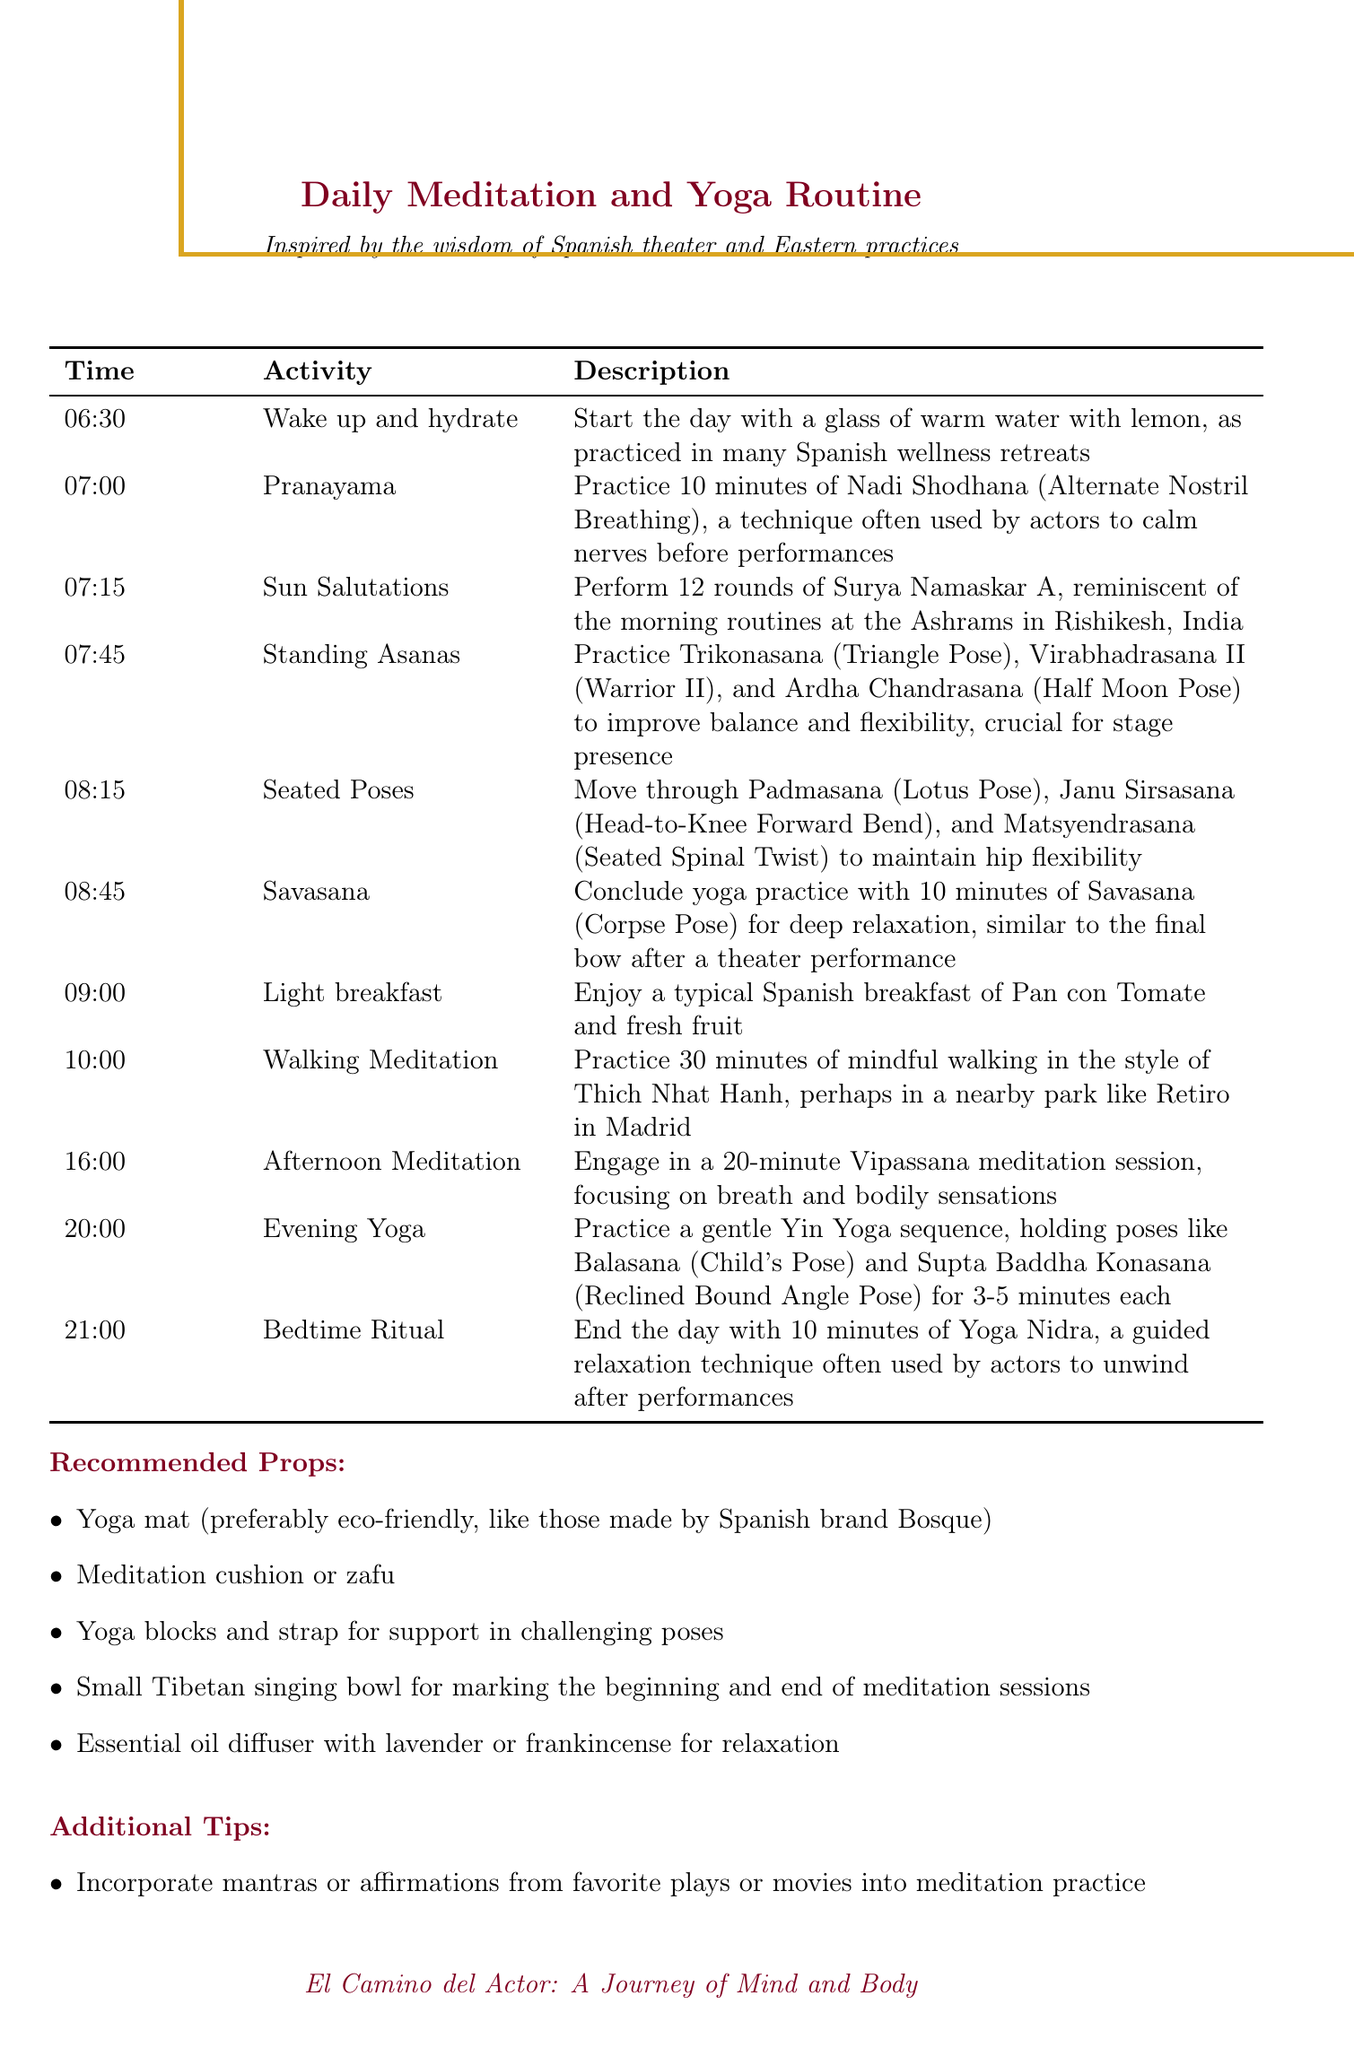what time does the daily routine start? The daily routine starts at 06:30, which is the time for waking up and hydrating.
Answer: 06:30 how long is the morning yoga practice? The morning yoga practice includes multiple activities from 07:00 to 08:45, which totals to 1 hour and 45 minutes.
Answer: 1 hour and 45 minutes what type of meditation is practiced in the afternoon? The afternoon meditation session involves Vipassana meditation, focusing on breath and bodily sensations.
Answer: Vipassana what is the recommended yoga mat brand? The document mentions an eco-friendly yoga mat made by the Spanish brand Bosque.
Answer: Bosque how many rounds of Sun Salutations are performed? The routine specifies performing 12 rounds of Surya Namaskar A (Sun Salutations).
Answer: 12 what pose concludes the morning yoga practice? The morning yoga practice concludes with 10 minutes of Savasana (Corpse Pose).
Answer: Savasana how many types of props are recommended? The document lists five different recommended props for yoga and meditation practices.
Answer: Five what is included in the light breakfast? The light breakfast consists of Pan con Tomate and fresh fruit, typical of Spanish cuisine.
Answer: Pan con Tomate and fresh fruit what activity follows the walking meditation? The walking meditation is followed by an afternoon meditation session at 16:00.
Answer: Afternoon Meditation 